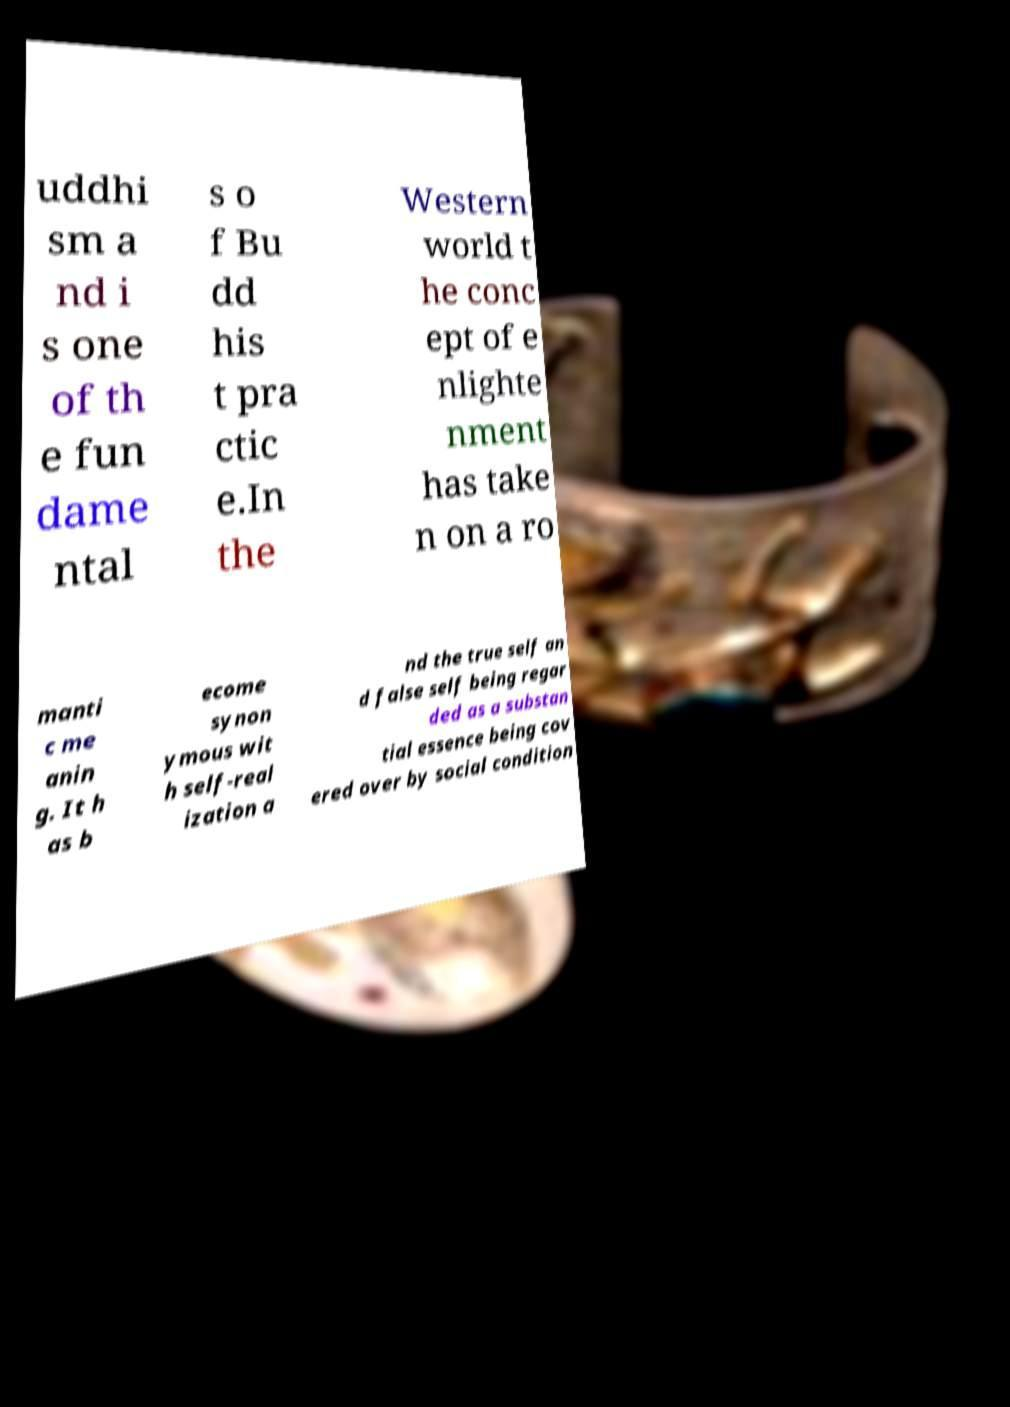I need the written content from this picture converted into text. Can you do that? uddhi sm a nd i s one of th e fun dame ntal s o f Bu dd his t pra ctic e.In the Western world t he conc ept of e nlighte nment has take n on a ro manti c me anin g. It h as b ecome synon ymous wit h self-real ization a nd the true self an d false self being regar ded as a substan tial essence being cov ered over by social condition 